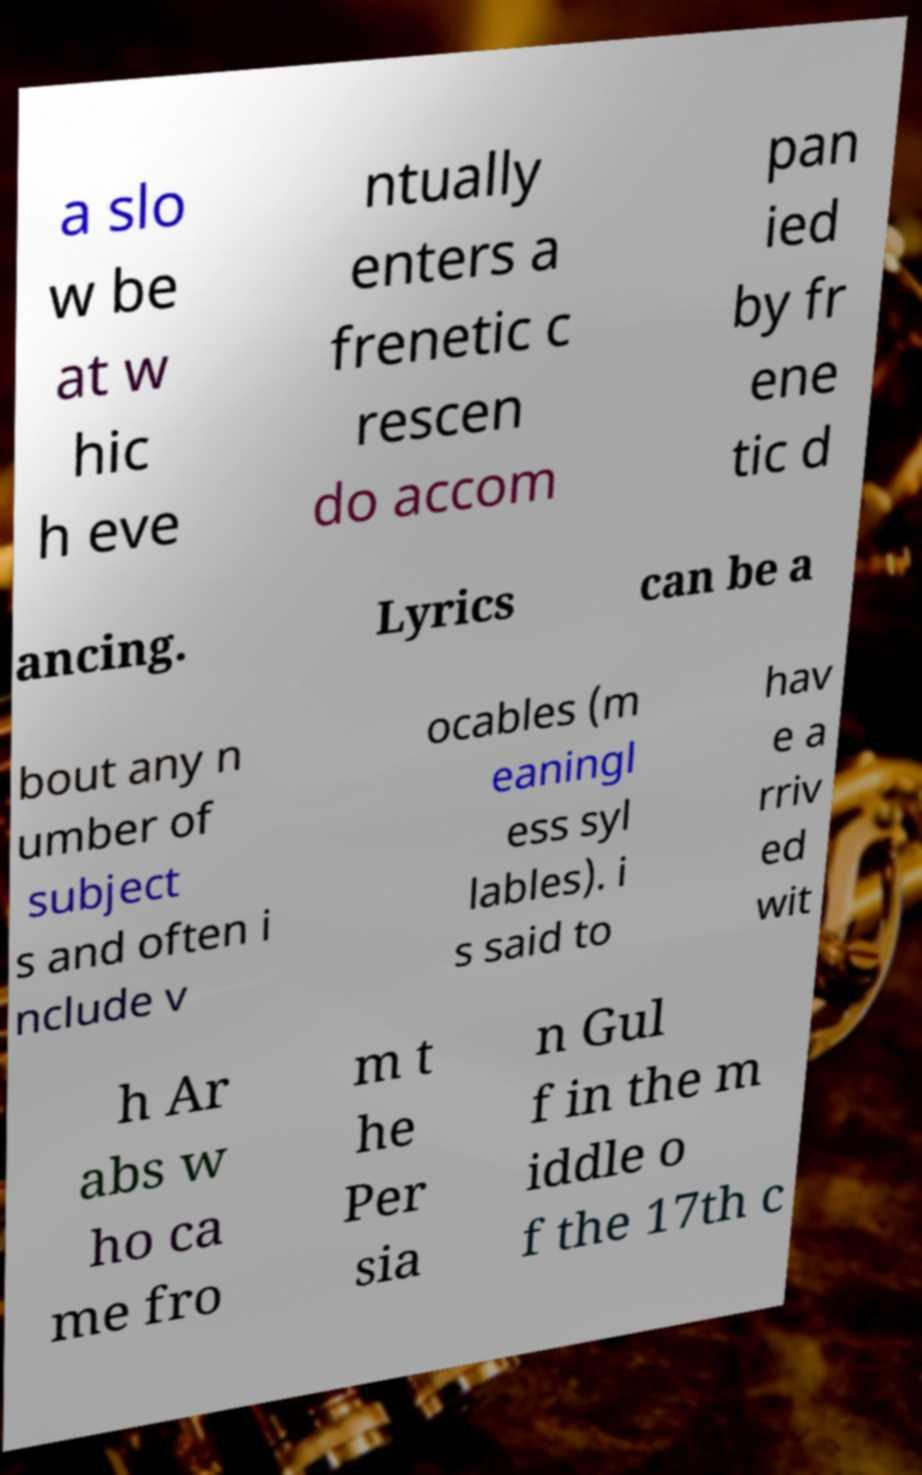Could you extract and type out the text from this image? a slo w be at w hic h eve ntually enters a frenetic c rescen do accom pan ied by fr ene tic d ancing. Lyrics can be a bout any n umber of subject s and often i nclude v ocables (m eaningl ess syl lables). i s said to hav e a rriv ed wit h Ar abs w ho ca me fro m t he Per sia n Gul f in the m iddle o f the 17th c 